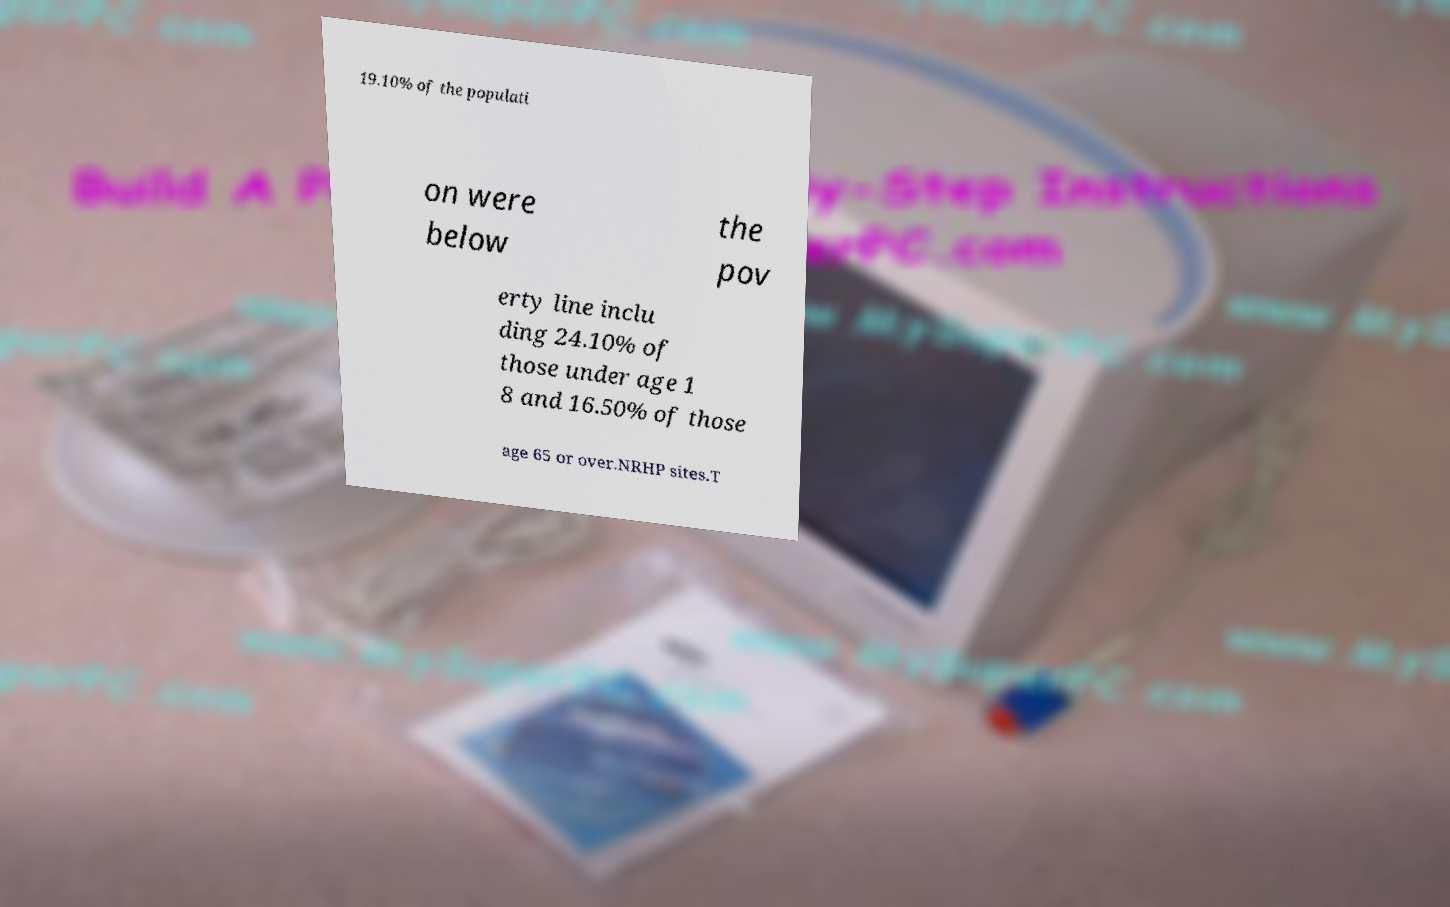Please identify and transcribe the text found in this image. 19.10% of the populati on were below the pov erty line inclu ding 24.10% of those under age 1 8 and 16.50% of those age 65 or over.NRHP sites.T 